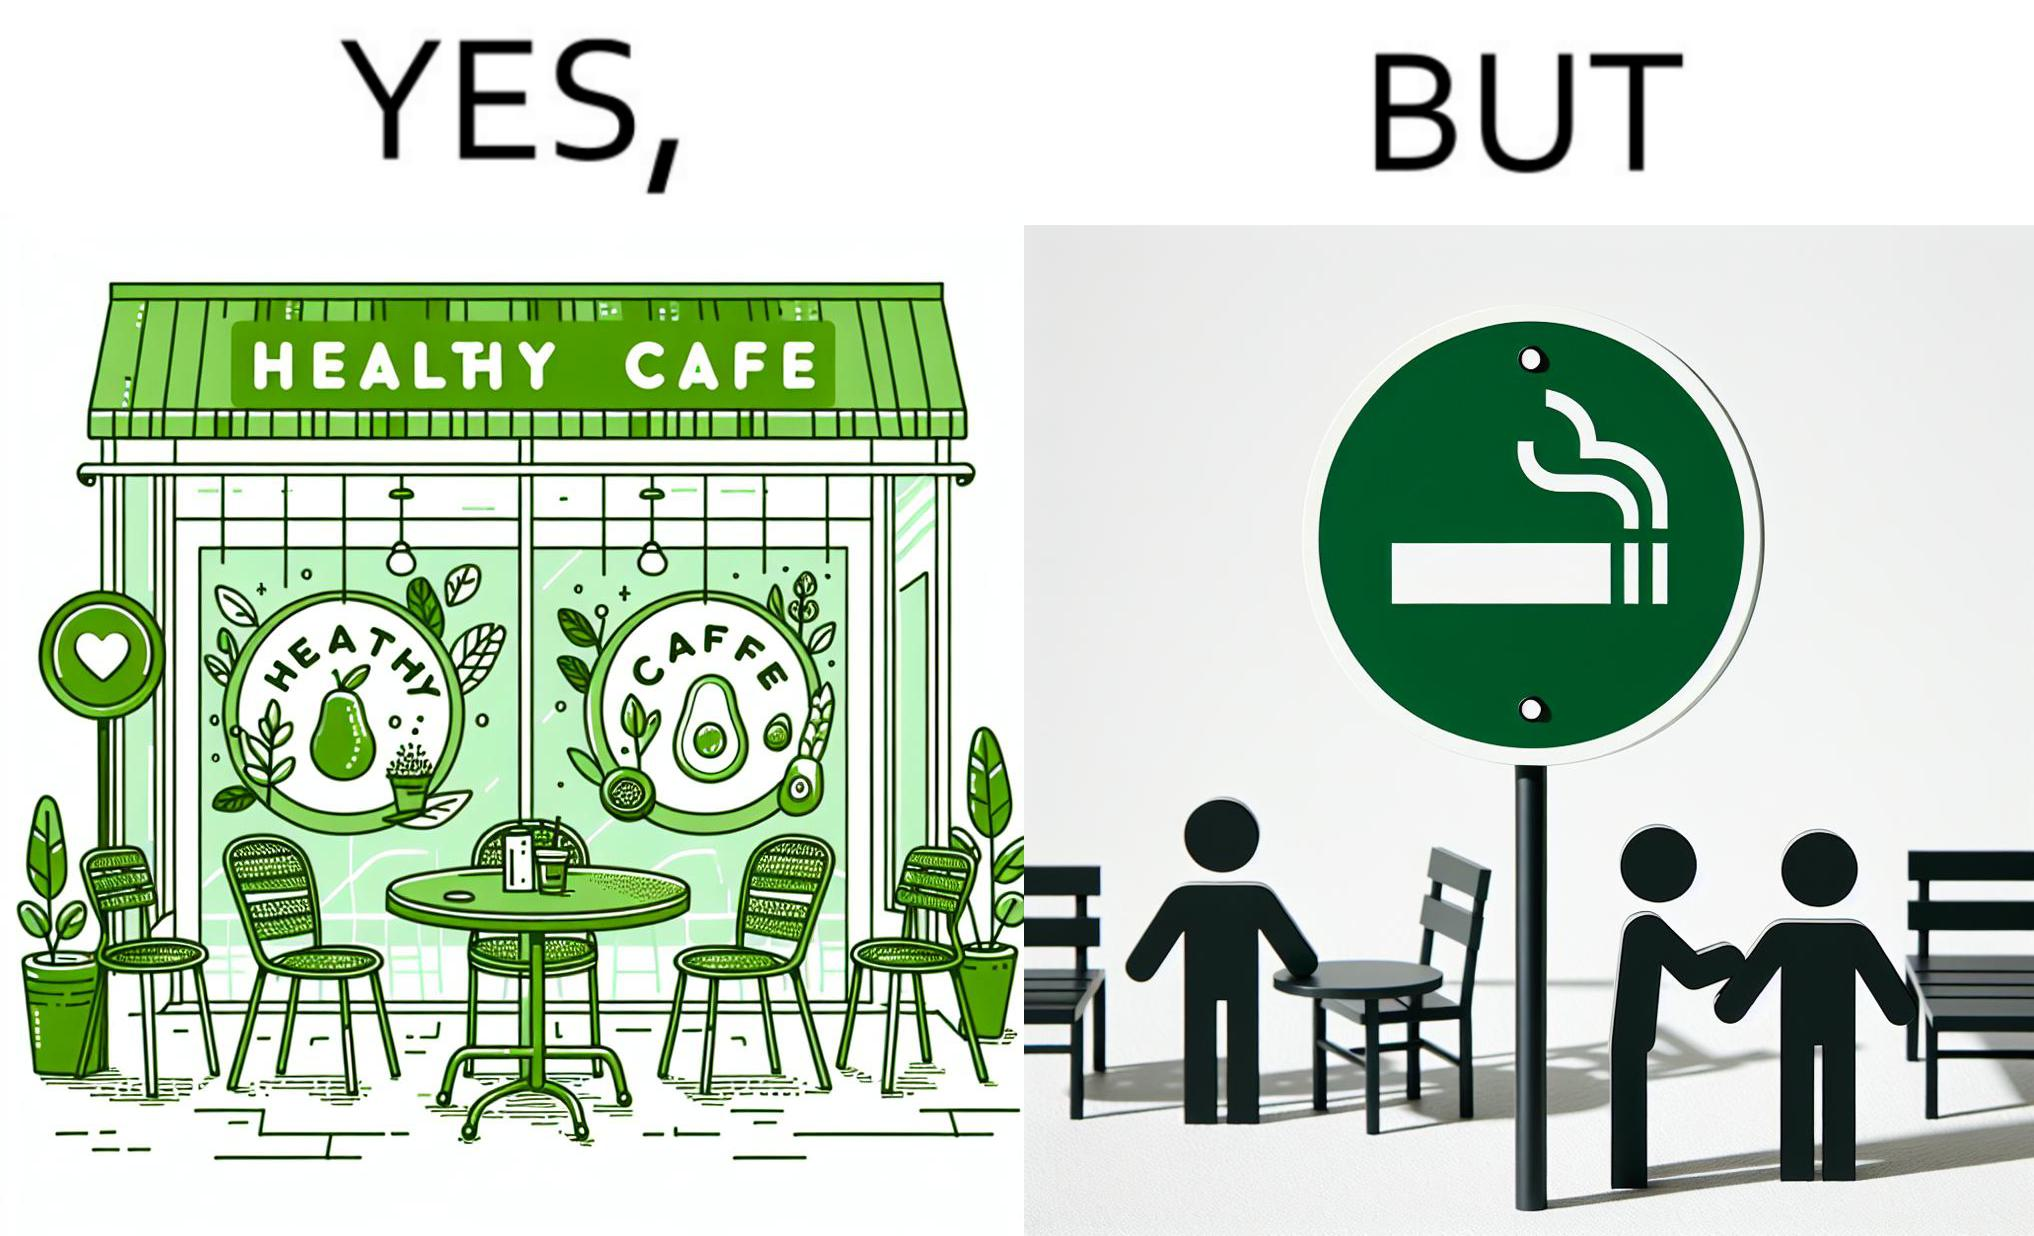Describe what you see in the left and right parts of this image. In the left part of the image: An eatery with the name "Healthy Cafe". It has a green aesthetic with paintings of leaves, avocados, etc on their windows. They have an outdoor seating area with 4 green patio chairs around a circular table. There is a small sign on a stand near the table with a green circular symbol and some text that is too small to read. In the right part of the image: Green patio chairs. A sign on a stand that has a green circular symbol encircling a cigarette symbol, and some text that says "SMOKING AREA". 